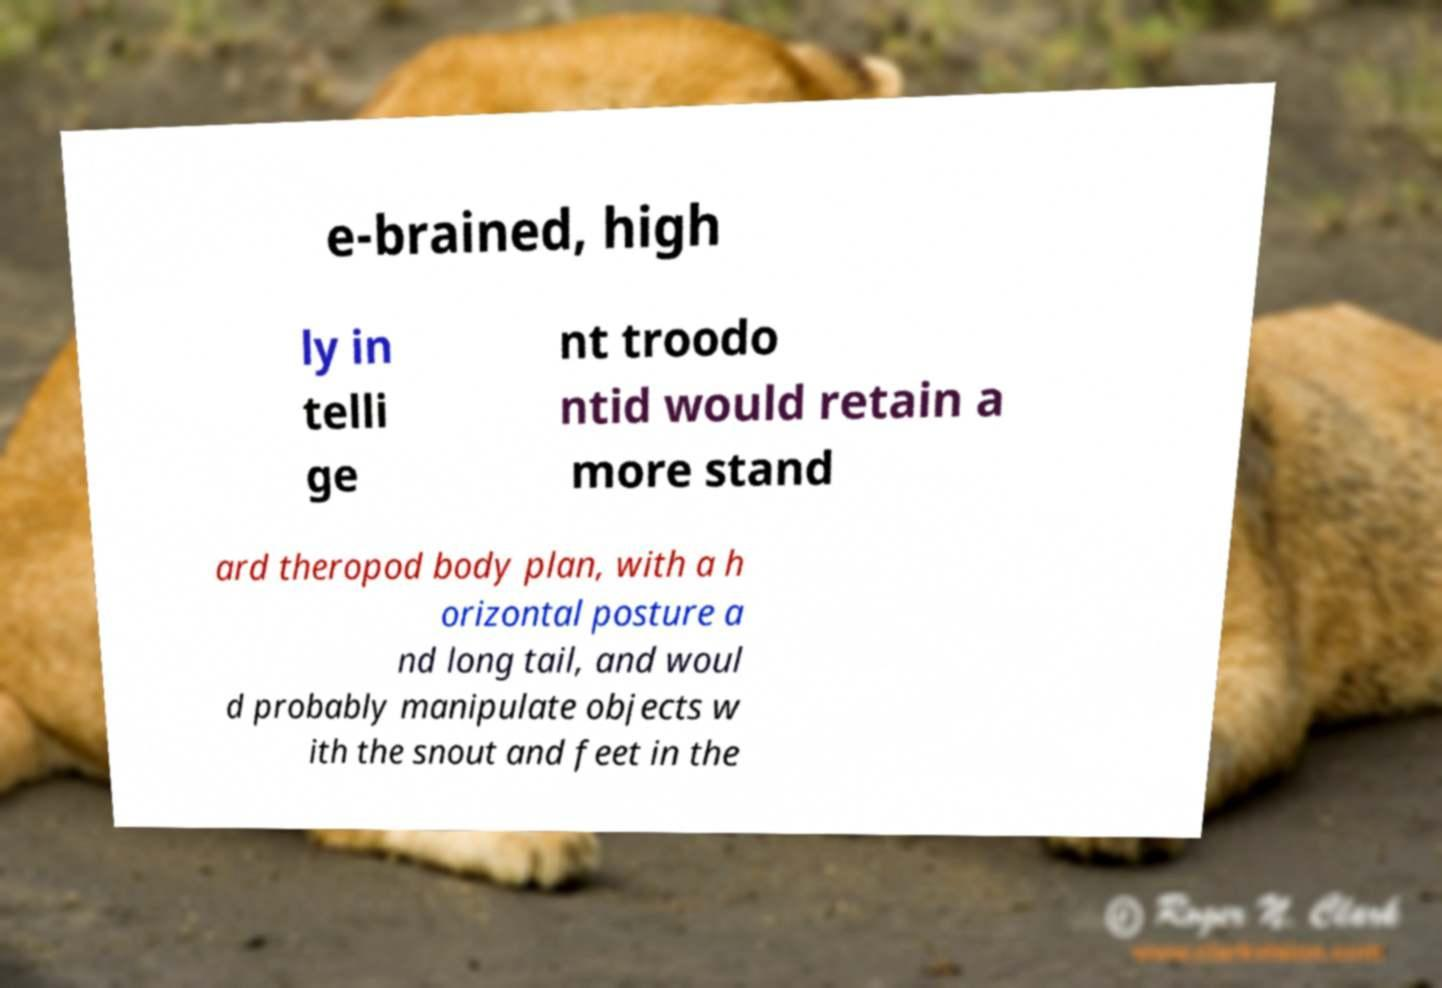Could you extract and type out the text from this image? e-brained, high ly in telli ge nt troodo ntid would retain a more stand ard theropod body plan, with a h orizontal posture a nd long tail, and woul d probably manipulate objects w ith the snout and feet in the 